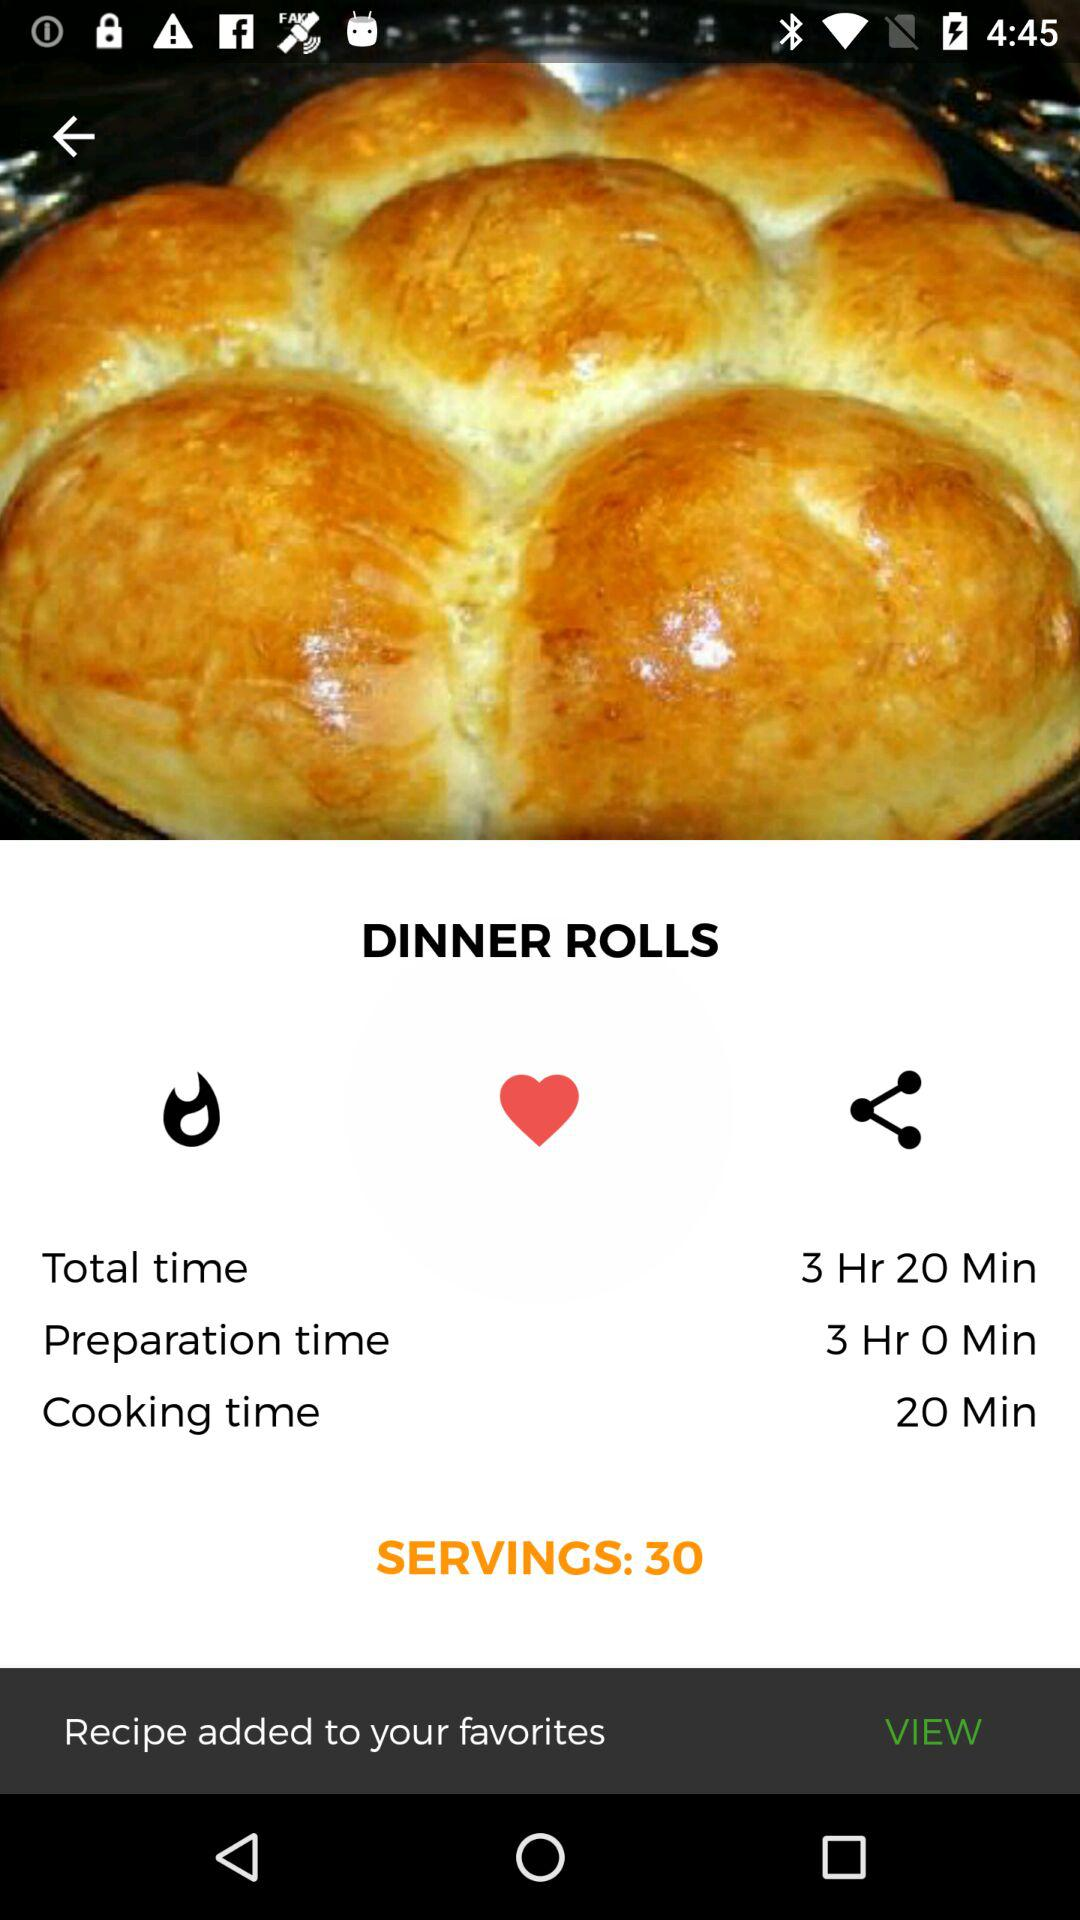How many servings does the recipe make?
Answer the question using a single word or phrase. 30 